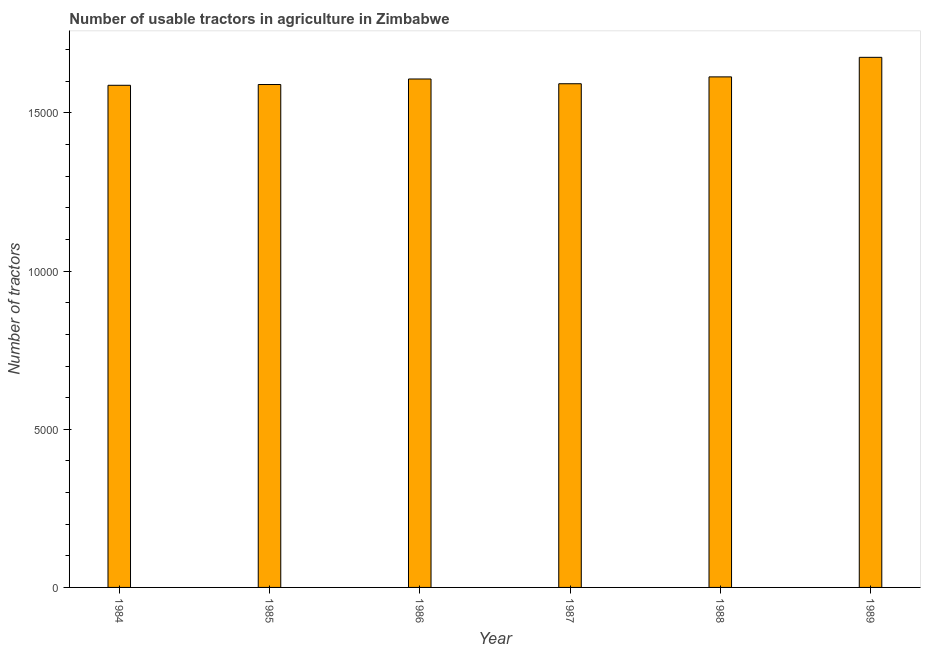Does the graph contain grids?
Offer a terse response. No. What is the title of the graph?
Your answer should be compact. Number of usable tractors in agriculture in Zimbabwe. What is the label or title of the Y-axis?
Make the answer very short. Number of tractors. What is the number of tractors in 1986?
Keep it short and to the point. 1.61e+04. Across all years, what is the maximum number of tractors?
Your answer should be very brief. 1.68e+04. Across all years, what is the minimum number of tractors?
Provide a short and direct response. 1.59e+04. In which year was the number of tractors minimum?
Give a very brief answer. 1984. What is the sum of the number of tractors?
Your answer should be very brief. 9.67e+04. What is the difference between the number of tractors in 1984 and 1987?
Offer a terse response. -49. What is the average number of tractors per year?
Keep it short and to the point. 1.61e+04. What is the median number of tractors?
Your answer should be very brief. 1.60e+04. In how many years, is the number of tractors greater than 10000 ?
Offer a very short reply. 6. Do a majority of the years between 1984 and 1985 (inclusive) have number of tractors greater than 6000 ?
Your response must be concise. Yes. Is the difference between the number of tractors in 1988 and 1989 greater than the difference between any two years?
Ensure brevity in your answer.  No. What is the difference between the highest and the second highest number of tractors?
Your answer should be very brief. 618. Is the sum of the number of tractors in 1984 and 1989 greater than the maximum number of tractors across all years?
Offer a terse response. Yes. What is the difference between the highest and the lowest number of tractors?
Offer a very short reply. 884. Are all the bars in the graph horizontal?
Keep it short and to the point. No. What is the difference between two consecutive major ticks on the Y-axis?
Provide a succinct answer. 5000. Are the values on the major ticks of Y-axis written in scientific E-notation?
Provide a short and direct response. No. What is the Number of tractors of 1984?
Your answer should be compact. 1.59e+04. What is the Number of tractors of 1985?
Offer a very short reply. 1.59e+04. What is the Number of tractors in 1986?
Provide a short and direct response. 1.61e+04. What is the Number of tractors of 1987?
Keep it short and to the point. 1.59e+04. What is the Number of tractors in 1988?
Your response must be concise. 1.61e+04. What is the Number of tractors in 1989?
Your answer should be very brief. 1.68e+04. What is the difference between the Number of tractors in 1984 and 1986?
Provide a succinct answer. -199. What is the difference between the Number of tractors in 1984 and 1987?
Your response must be concise. -49. What is the difference between the Number of tractors in 1984 and 1988?
Your answer should be very brief. -266. What is the difference between the Number of tractors in 1984 and 1989?
Your answer should be compact. -884. What is the difference between the Number of tractors in 1985 and 1986?
Your answer should be very brief. -175. What is the difference between the Number of tractors in 1985 and 1987?
Your answer should be compact. -25. What is the difference between the Number of tractors in 1985 and 1988?
Give a very brief answer. -242. What is the difference between the Number of tractors in 1985 and 1989?
Your answer should be very brief. -860. What is the difference between the Number of tractors in 1986 and 1987?
Offer a very short reply. 150. What is the difference between the Number of tractors in 1986 and 1988?
Offer a terse response. -67. What is the difference between the Number of tractors in 1986 and 1989?
Provide a succinct answer. -685. What is the difference between the Number of tractors in 1987 and 1988?
Offer a very short reply. -217. What is the difference between the Number of tractors in 1987 and 1989?
Give a very brief answer. -835. What is the difference between the Number of tractors in 1988 and 1989?
Offer a very short reply. -618. What is the ratio of the Number of tractors in 1984 to that in 1986?
Make the answer very short. 0.99. What is the ratio of the Number of tractors in 1984 to that in 1989?
Provide a succinct answer. 0.95. What is the ratio of the Number of tractors in 1985 to that in 1986?
Provide a short and direct response. 0.99. What is the ratio of the Number of tractors in 1985 to that in 1989?
Your response must be concise. 0.95. What is the ratio of the Number of tractors in 1986 to that in 1988?
Give a very brief answer. 1. What is the ratio of the Number of tractors in 1986 to that in 1989?
Offer a very short reply. 0.96. What is the ratio of the Number of tractors in 1987 to that in 1989?
Offer a terse response. 0.95. 